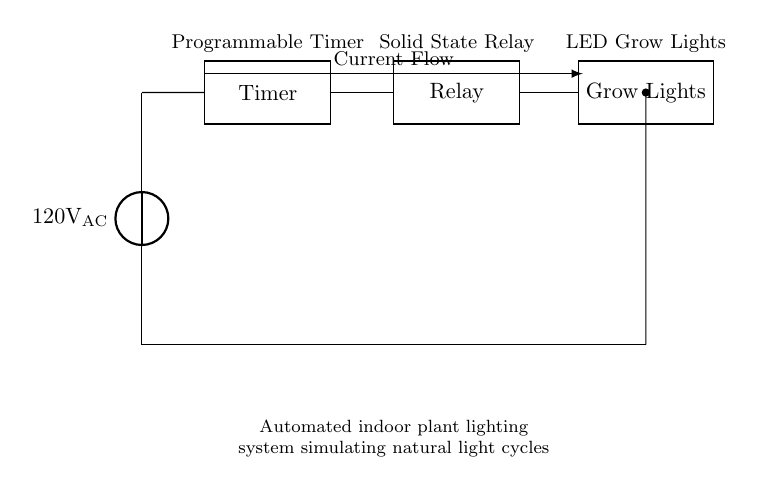What is the power source voltage in this circuit? The circuit is powered by a voltage source labeled as 120 volts AC, which can be seen from the voltage source symbol in the circuit diagram.
Answer: 120 volts AC What is the function of the timer in this circuit? The timer is a programmable device that controls the on and off cycles of the grow lights, simulating natural light cycles for the plants. This can be inferred from its position in the circuit, between the power source and the relay.
Answer: Programmable device What type of relay is used in this circuit? The circuit diagram indicates a solid-state relay, as mentioned in the label above the relay component. This type of relay is typically used to control high power loads like grow lights.
Answer: Solid state How many main components are in the circuit? The circuit contains three main components: a timer, a relay, and grow lights. Counting these components gives the total of three.
Answer: Three What is the role of the relay in this circuit? The relay acts as a switch controlled by the timer that allows or prevents current flow to the grow lights. This is deduced from its position after the timer and before the lights in the circuit.
Answer: Switch What is the direction of current flow in the circuit? The circuit diagram shows the direction of current flow as indicated by the arrow from the timer, through the relay, to the grow lights, ultimately suggesting a continuous path when activated.
Answer: Left to right 